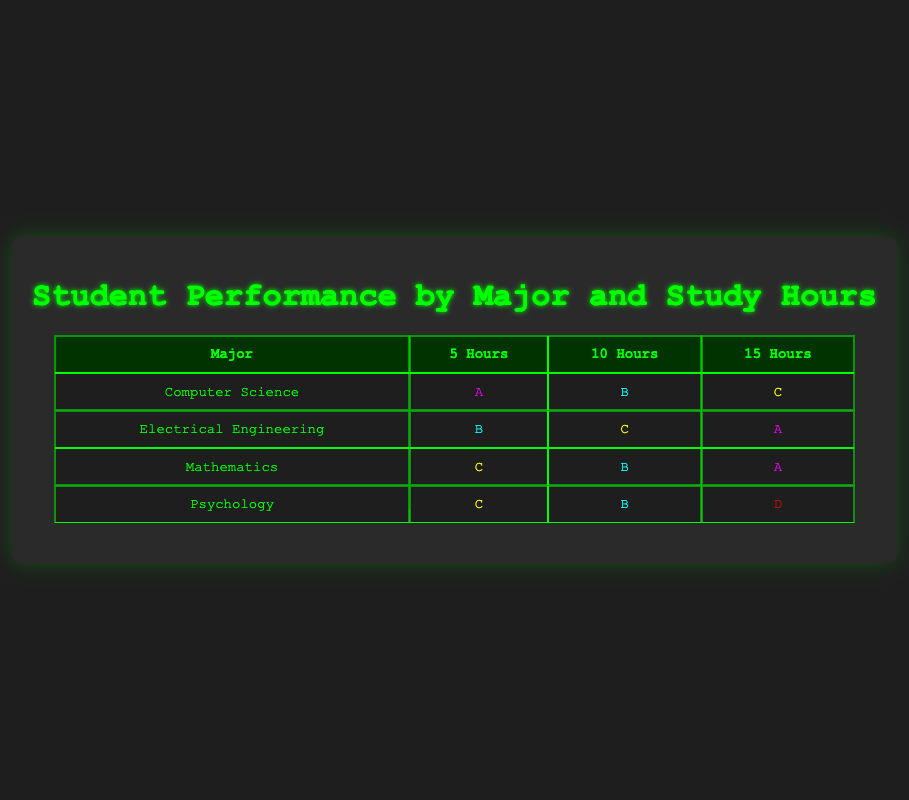What performance did Computer Science students achieve with 15 study hours? Looking at the row for Computer Science in the 15 Hours column, the performance recorded is C.
Answer: C Which major had the highest performance for students studying 10 hours? In the 10 Hours column, Mathematics has a performance of B, which is highest compared to Computer Science (B), Electrical Engineering (C), and Psychology (B).
Answer: Mathematics Is it true that all majors had at least one student who scored an A? Yes, upon inspecting the table, Computer Science, Electrical Engineering, and Mathematics each have at least one A: Computer Science (5 hours), Electrical Engineering (15 hours), Mathematics (15 hours). Psychology does not have an A.
Answer: No What is the average performance level for Psychology students based on study hours? Counting the performances for Psychology: C (5 hours), B (10 hours), D (15 hours). These can be converted to numerical values: C = 2, B = 3, D = 1. Average is (2 + 3 + 1) / 3 = 2. The average performance level corresponds to a C.
Answer: C How many total students are represented in the table? By counting the unique entries, we have 4 majors, each represented by performances across 3 different study hours, resulting in a total of 4 * 3 = 12 students.
Answer: 12 Which major shows a decrease in performance as study hours increase from 5 to 15 hours? Observing the performance of Computer Science, it goes from A (5 hours) to B (10 hours) to C (15 hours). This indicates a decrease in performance with increased study hours.
Answer: Computer Science What is the difference in performance between the highest and lowest scoring students in Mathematics? In the Mathematics major, the highest performance is A (15 hours) and the lowest is C (5 hours). If A is valued at 4 and C at 2, the difference is 4 - 2 = 2, indicating a performance drop by two levels.
Answer: 2 How many performances are categorized as B for students who studied 10 hours? Looking specifically at the 10 Hours column, the performances are B (Computer Science), C (Electrical Engineering), B (Mathematics), and B (Psychology). Counting B's, we find three instances: Computer Science, Mathematics, and Psychology.
Answer: 3 Are any students in Electrical Engineering performing at a level lower than a B? Reviewing the performances for Electrical Engineering: B (5 hours), C (10 hours), A (15 hours). The C performance at 10 hours is indeed lower than B.
Answer: Yes 